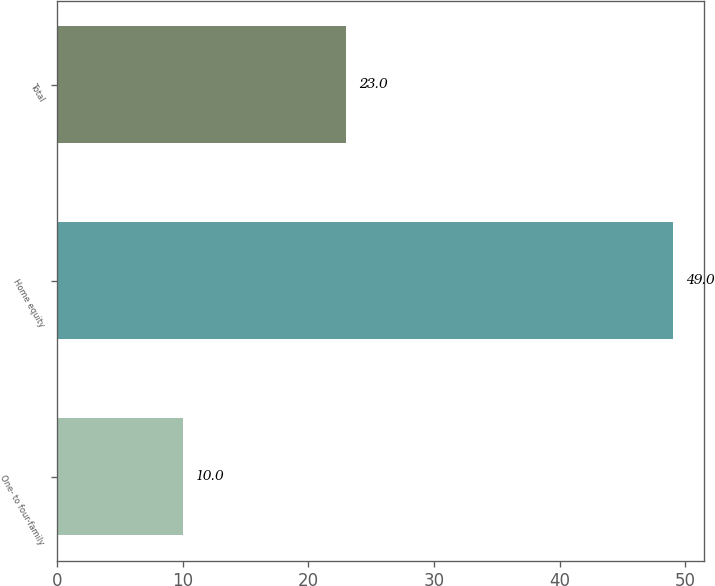Convert chart to OTSL. <chart><loc_0><loc_0><loc_500><loc_500><bar_chart><fcel>One- to four-family<fcel>Home equity<fcel>Total<nl><fcel>10<fcel>49<fcel>23<nl></chart> 